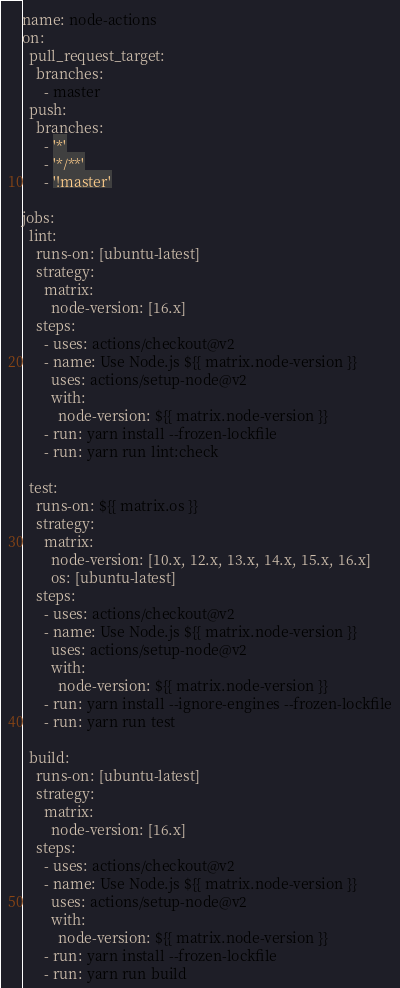Convert code to text. <code><loc_0><loc_0><loc_500><loc_500><_YAML_>name: node-actions
on:
  pull_request_target:
    branches:
      - master
  push:
    branches:
      - '*'
      - '*/**'
      - '!master'

jobs:
  lint:
    runs-on: [ubuntu-latest]
    strategy:
      matrix:
        node-version: [16.x]
    steps:
      - uses: actions/checkout@v2
      - name: Use Node.js ${{ matrix.node-version }}
        uses: actions/setup-node@v2
        with:
          node-version: ${{ matrix.node-version }}
      - run: yarn install --frozen-lockfile
      - run: yarn run lint:check

  test:
    runs-on: ${{ matrix.os }}
    strategy:
      matrix:
        node-version: [10.x, 12.x, 13.x, 14.x, 15.x, 16.x]
        os: [ubuntu-latest]
    steps:
      - uses: actions/checkout@v2
      - name: Use Node.js ${{ matrix.node-version }}
        uses: actions/setup-node@v2
        with:
          node-version: ${{ matrix.node-version }}
      - run: yarn install --ignore-engines --frozen-lockfile
      - run: yarn run test

  build:
    runs-on: [ubuntu-latest]
    strategy:
      matrix:
        node-version: [16.x]
    steps:
      - uses: actions/checkout@v2
      - name: Use Node.js ${{ matrix.node-version }}
        uses: actions/setup-node@v2
        with:
          node-version: ${{ matrix.node-version }}
      - run: yarn install --frozen-lockfile
      - run: yarn run build
</code> 